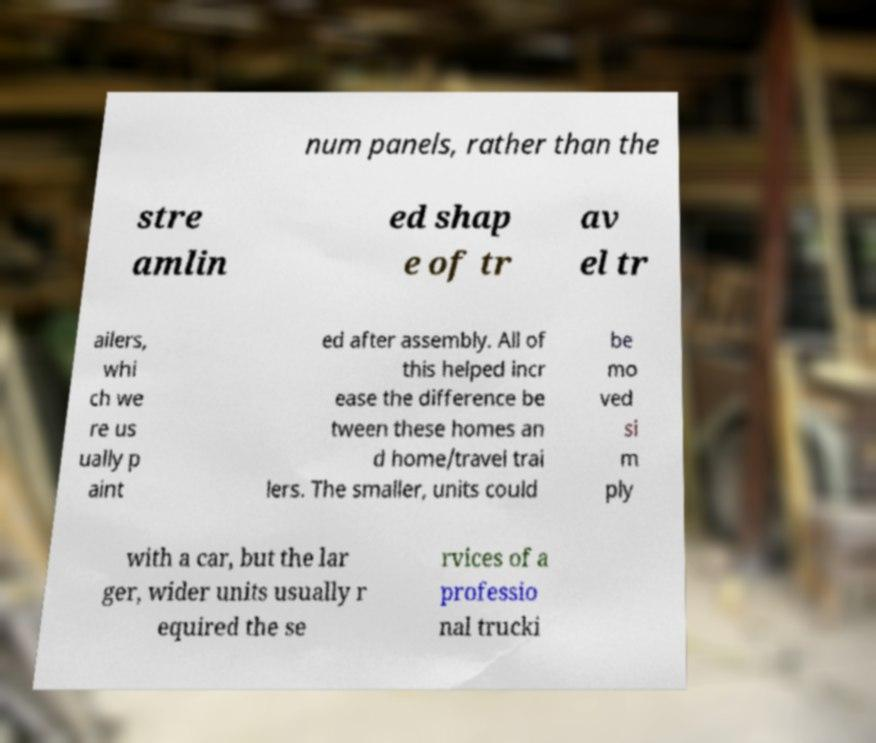Please read and relay the text visible in this image. What does it say? num panels, rather than the stre amlin ed shap e of tr av el tr ailers, whi ch we re us ually p aint ed after assembly. All of this helped incr ease the difference be tween these homes an d home/travel trai lers. The smaller, units could be mo ved si m ply with a car, but the lar ger, wider units usually r equired the se rvices of a professio nal trucki 